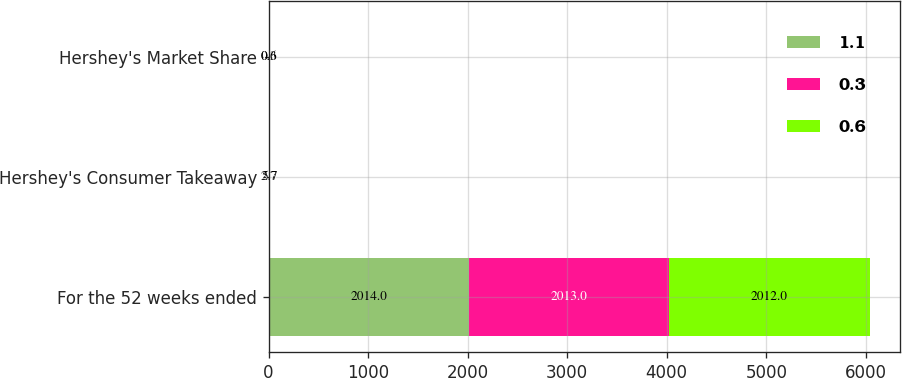Convert chart. <chart><loc_0><loc_0><loc_500><loc_500><stacked_bar_chart><ecel><fcel>For the 52 weeks ended<fcel>Hershey's Consumer Takeaway<fcel>Hershey's Market Share<nl><fcel>1.1<fcel>2014<fcel>2.7<fcel>0.3<nl><fcel>0.3<fcel>2013<fcel>6.3<fcel>1.1<nl><fcel>0.6<fcel>2012<fcel>5.7<fcel>0.6<nl></chart> 